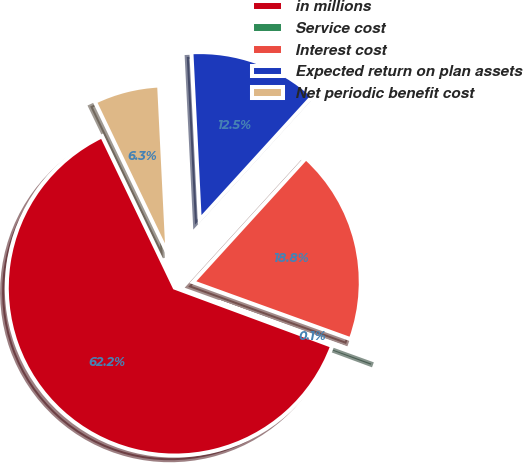Convert chart to OTSL. <chart><loc_0><loc_0><loc_500><loc_500><pie_chart><fcel>in millions<fcel>Service cost<fcel>Interest cost<fcel>Expected return on plan assets<fcel>Net periodic benefit cost<nl><fcel>62.24%<fcel>0.12%<fcel>18.76%<fcel>12.55%<fcel>6.33%<nl></chart> 